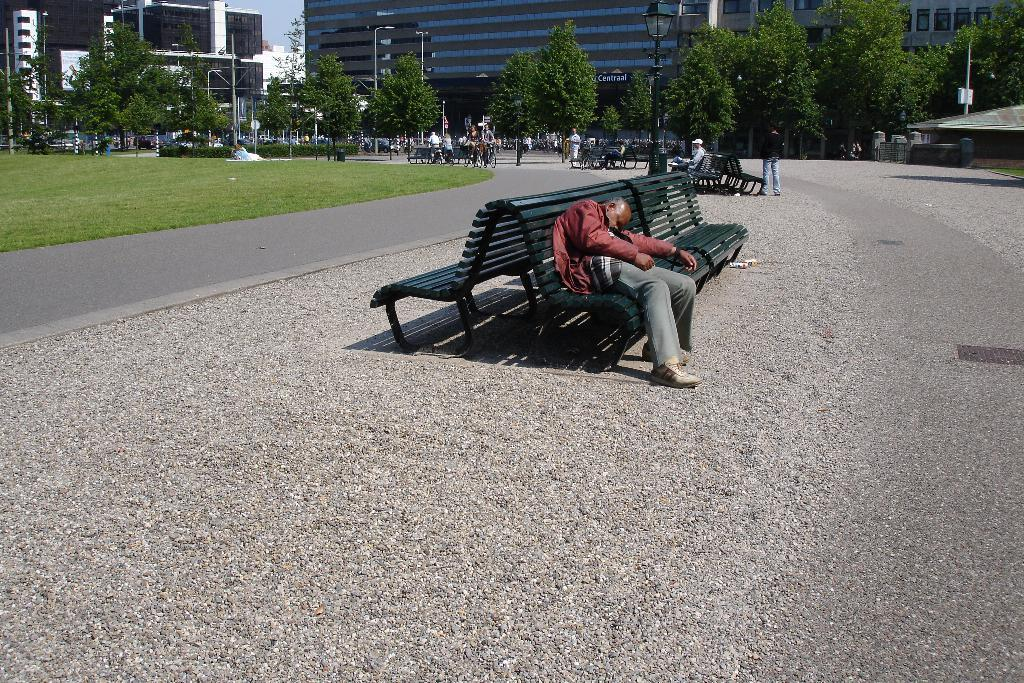What is the man in the image doing? The man is laying on a bench in the image. Where is the bench located in relation to other objects in the image? The bench is in the middle of the month. What can be seen in the background of the image? There is a building in the image. What type of vegetation is visible in front of the bench? There are many trees in front of the bench. What type of nail is being used to hold the bench together in the image? There is no nail visible in the image, and the bench's construction is not mentioned. 